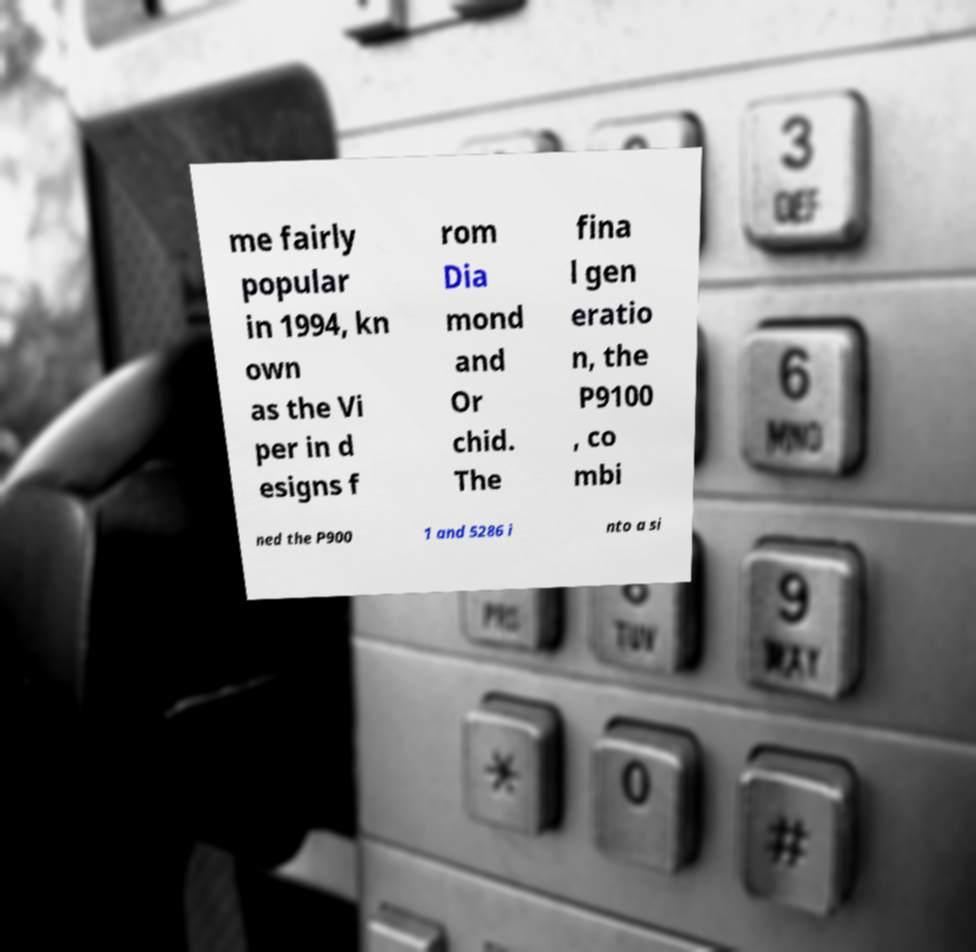For documentation purposes, I need the text within this image transcribed. Could you provide that? me fairly popular in 1994, kn own as the Vi per in d esigns f rom Dia mond and Or chid. The fina l gen eratio n, the P9100 , co mbi ned the P900 1 and 5286 i nto a si 